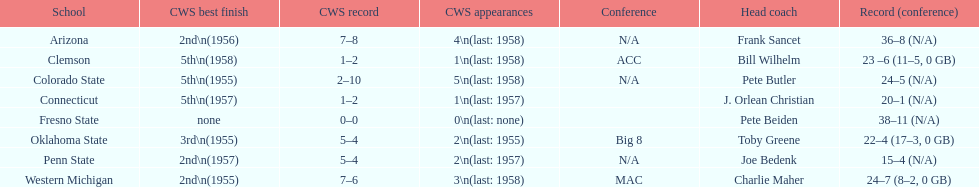Which educational institution has never participated in the college world series? Fresno State. 